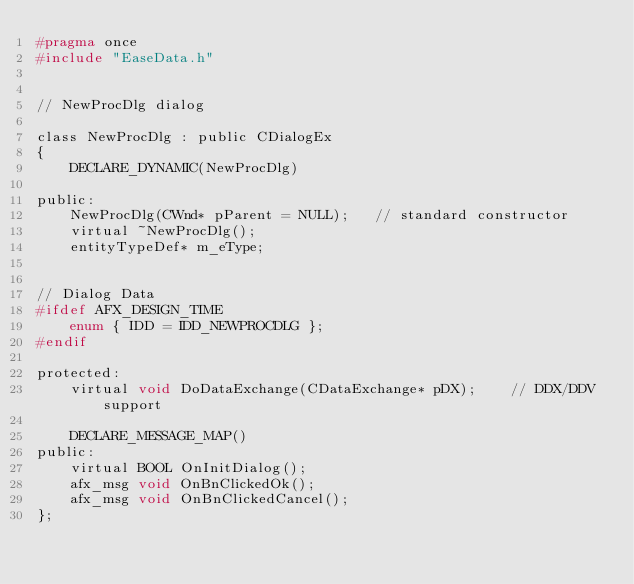<code> <loc_0><loc_0><loc_500><loc_500><_C_>#pragma once
#include "EaseData.h"


// NewProcDlg dialog

class NewProcDlg : public CDialogEx
{
	DECLARE_DYNAMIC(NewProcDlg)

public:
	NewProcDlg(CWnd* pParent = NULL);   // standard constructor
	virtual ~NewProcDlg();
	entityTypeDef* m_eType;


// Dialog Data
#ifdef AFX_DESIGN_TIME
	enum { IDD = IDD_NEWPROCDLG };
#endif

protected:
	virtual void DoDataExchange(CDataExchange* pDX);    // DDX/DDV support

	DECLARE_MESSAGE_MAP()
public:
	virtual BOOL OnInitDialog();
	afx_msg void OnBnClickedOk();
	afx_msg void OnBnClickedCancel();
};
</code> 